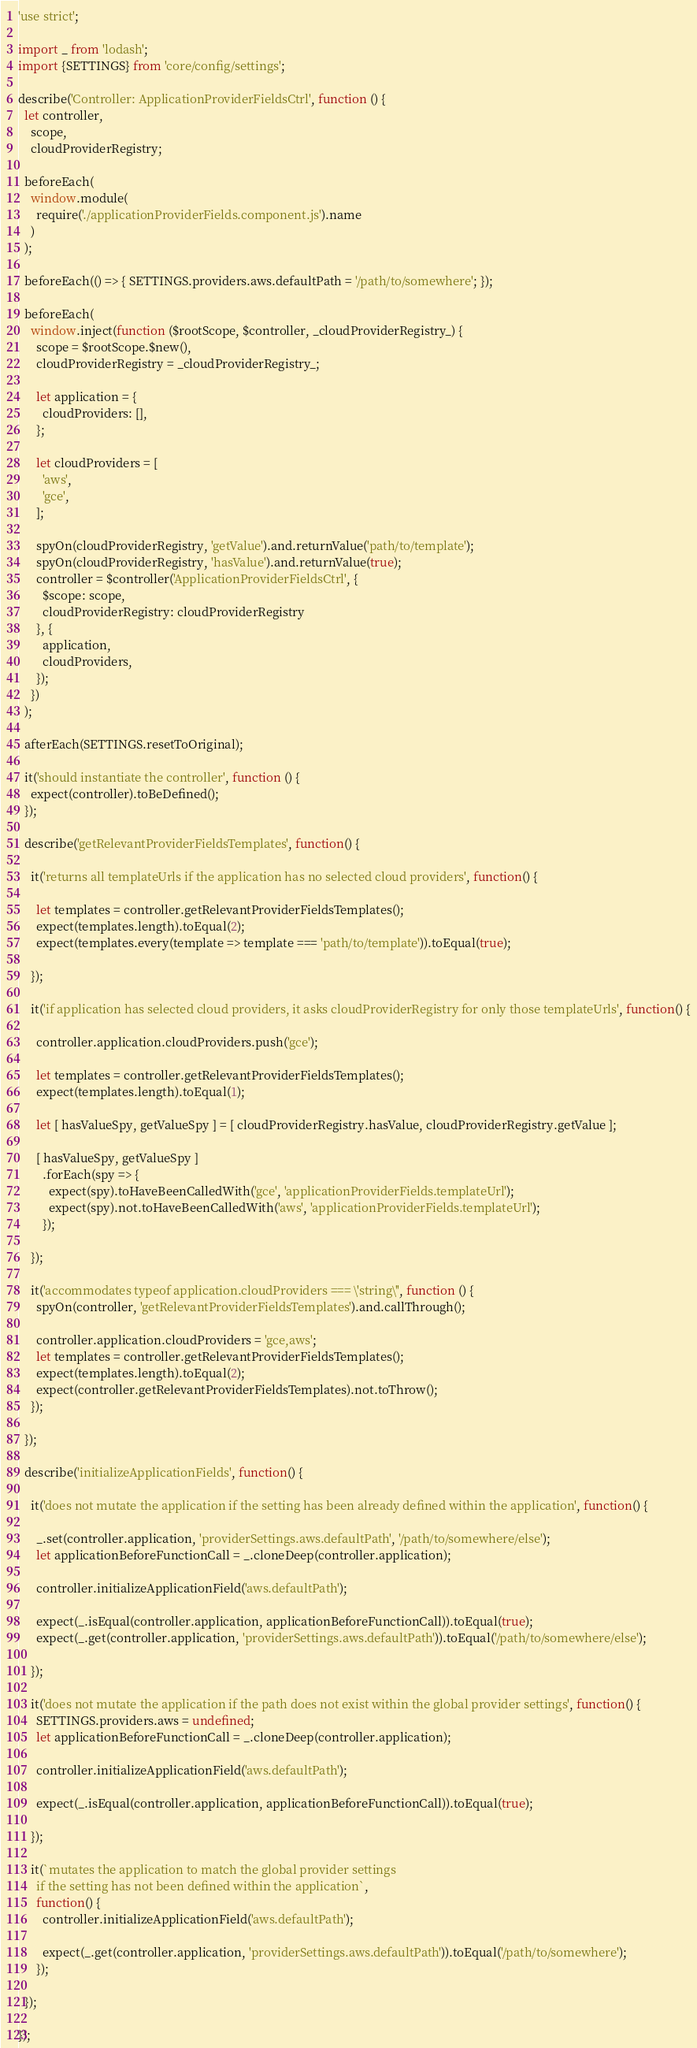<code> <loc_0><loc_0><loc_500><loc_500><_JavaScript_>'use strict';

import _ from 'lodash';
import {SETTINGS} from 'core/config/settings';

describe('Controller: ApplicationProviderFieldsCtrl', function () {
  let controller,
    scope,
    cloudProviderRegistry;

  beforeEach(
    window.module(
      require('./applicationProviderFields.component.js').name
    )
  );

  beforeEach(() => { SETTINGS.providers.aws.defaultPath = '/path/to/somewhere'; });

  beforeEach(
    window.inject(function ($rootScope, $controller, _cloudProviderRegistry_) {
      scope = $rootScope.$new(),
      cloudProviderRegistry = _cloudProviderRegistry_;

      let application = {
        cloudProviders: [],
      };

      let cloudProviders = [
        'aws',
        'gce',
      ];

      spyOn(cloudProviderRegistry, 'getValue').and.returnValue('path/to/template');
      spyOn(cloudProviderRegistry, 'hasValue').and.returnValue(true);
      controller = $controller('ApplicationProviderFieldsCtrl', {
        $scope: scope,
        cloudProviderRegistry: cloudProviderRegistry
      }, {
        application,
        cloudProviders,
      });
    })
  );

  afterEach(SETTINGS.resetToOriginal);

  it('should instantiate the controller', function () {
    expect(controller).toBeDefined();
  });

  describe('getRelevantProviderFieldsTemplates', function() {

    it('returns all templateUrls if the application has no selected cloud providers', function() {

      let templates = controller.getRelevantProviderFieldsTemplates();
      expect(templates.length).toEqual(2);
      expect(templates.every(template => template === 'path/to/template')).toEqual(true);

    });

    it('if application has selected cloud providers, it asks cloudProviderRegistry for only those templateUrls', function() {

      controller.application.cloudProviders.push('gce');

      let templates = controller.getRelevantProviderFieldsTemplates();
      expect(templates.length).toEqual(1);

      let [ hasValueSpy, getValueSpy ] = [ cloudProviderRegistry.hasValue, cloudProviderRegistry.getValue ];

      [ hasValueSpy, getValueSpy ]
        .forEach(spy => {
          expect(spy).toHaveBeenCalledWith('gce', 'applicationProviderFields.templateUrl');
          expect(spy).not.toHaveBeenCalledWith('aws', 'applicationProviderFields.templateUrl');
        });

    });

    it('accommodates typeof application.cloudProviders === \'string\'', function () {
      spyOn(controller, 'getRelevantProviderFieldsTemplates').and.callThrough();

      controller.application.cloudProviders = 'gce,aws';
      let templates = controller.getRelevantProviderFieldsTemplates();
      expect(templates.length).toEqual(2);
      expect(controller.getRelevantProviderFieldsTemplates).not.toThrow();
    });

  });

  describe('initializeApplicationFields', function() {

    it('does not mutate the application if the setting has been already defined within the application', function() {

      _.set(controller.application, 'providerSettings.aws.defaultPath', '/path/to/somewhere/else');
      let applicationBeforeFunctionCall = _.cloneDeep(controller.application);

      controller.initializeApplicationField('aws.defaultPath');

      expect(_.isEqual(controller.application, applicationBeforeFunctionCall)).toEqual(true);
      expect(_.get(controller.application, 'providerSettings.aws.defaultPath')).toEqual('/path/to/somewhere/else');

    });

    it('does not mutate the application if the path does not exist within the global provider settings', function() {
      SETTINGS.providers.aws = undefined;
      let applicationBeforeFunctionCall = _.cloneDeep(controller.application);

      controller.initializeApplicationField('aws.defaultPath');

      expect(_.isEqual(controller.application, applicationBeforeFunctionCall)).toEqual(true);

    });

    it(`mutates the application to match the global provider settings
      if the setting has not been defined within the application`,
      function() {
        controller.initializeApplicationField('aws.defaultPath');

        expect(_.get(controller.application, 'providerSettings.aws.defaultPath')).toEqual('/path/to/somewhere');
      });

  });

});
</code> 